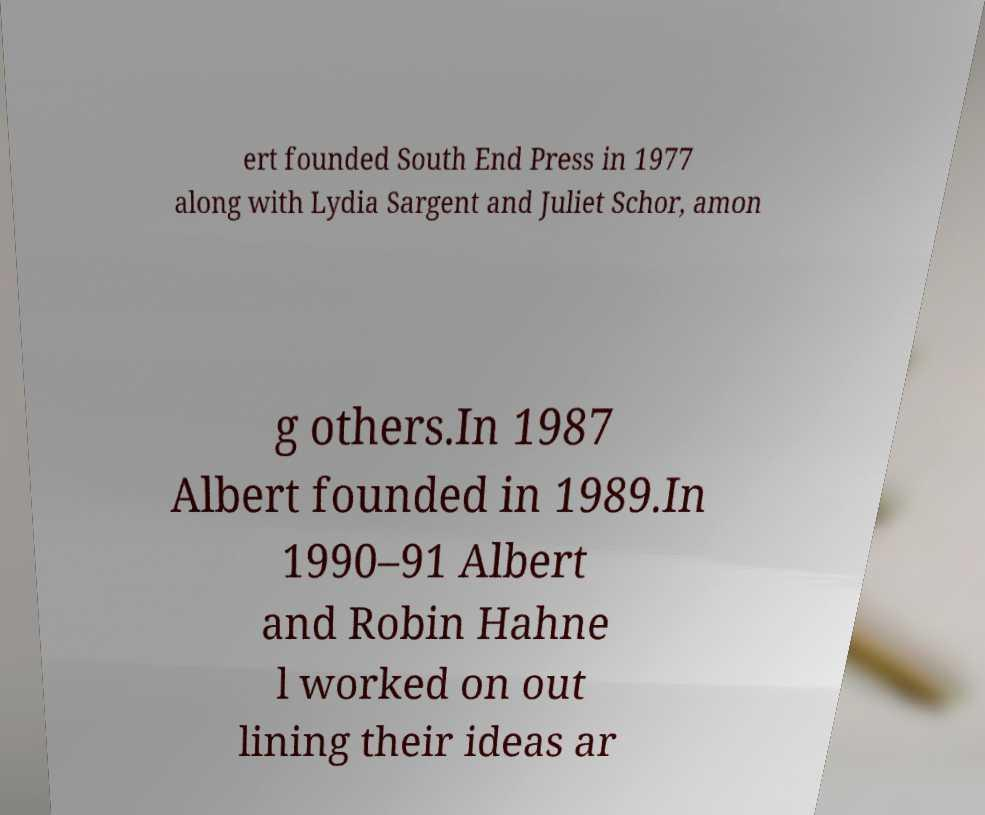What messages or text are displayed in this image? I need them in a readable, typed format. ert founded South End Press in 1977 along with Lydia Sargent and Juliet Schor, amon g others.In 1987 Albert founded in 1989.In 1990–91 Albert and Robin Hahne l worked on out lining their ideas ar 